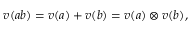Convert formula to latex. <formula><loc_0><loc_0><loc_500><loc_500>v ( a b ) = v ( a ) + v ( b ) = v ( a ) \otimes v ( b ) ,</formula> 